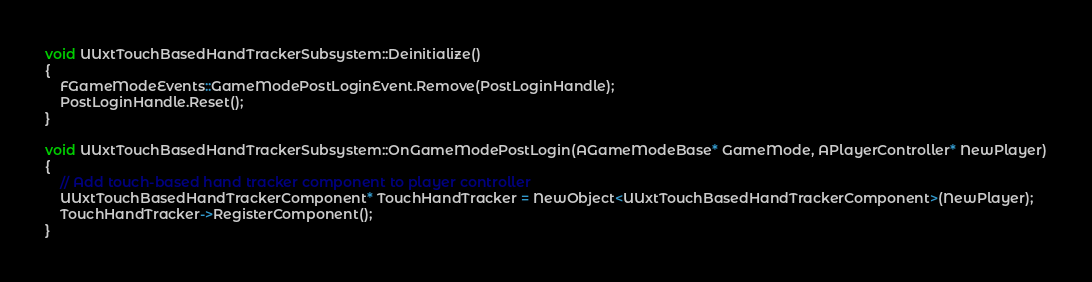Convert code to text. <code><loc_0><loc_0><loc_500><loc_500><_C++_>void UUxtTouchBasedHandTrackerSubsystem::Deinitialize()
{
	FGameModeEvents::GameModePostLoginEvent.Remove(PostLoginHandle);
	PostLoginHandle.Reset();
}

void UUxtTouchBasedHandTrackerSubsystem::OnGameModePostLogin(AGameModeBase* GameMode, APlayerController* NewPlayer)
{
	// Add touch-based hand tracker component to player controller
	UUxtTouchBasedHandTrackerComponent* TouchHandTracker = NewObject<UUxtTouchBasedHandTrackerComponent>(NewPlayer);
	TouchHandTracker->RegisterComponent();
}
</code> 